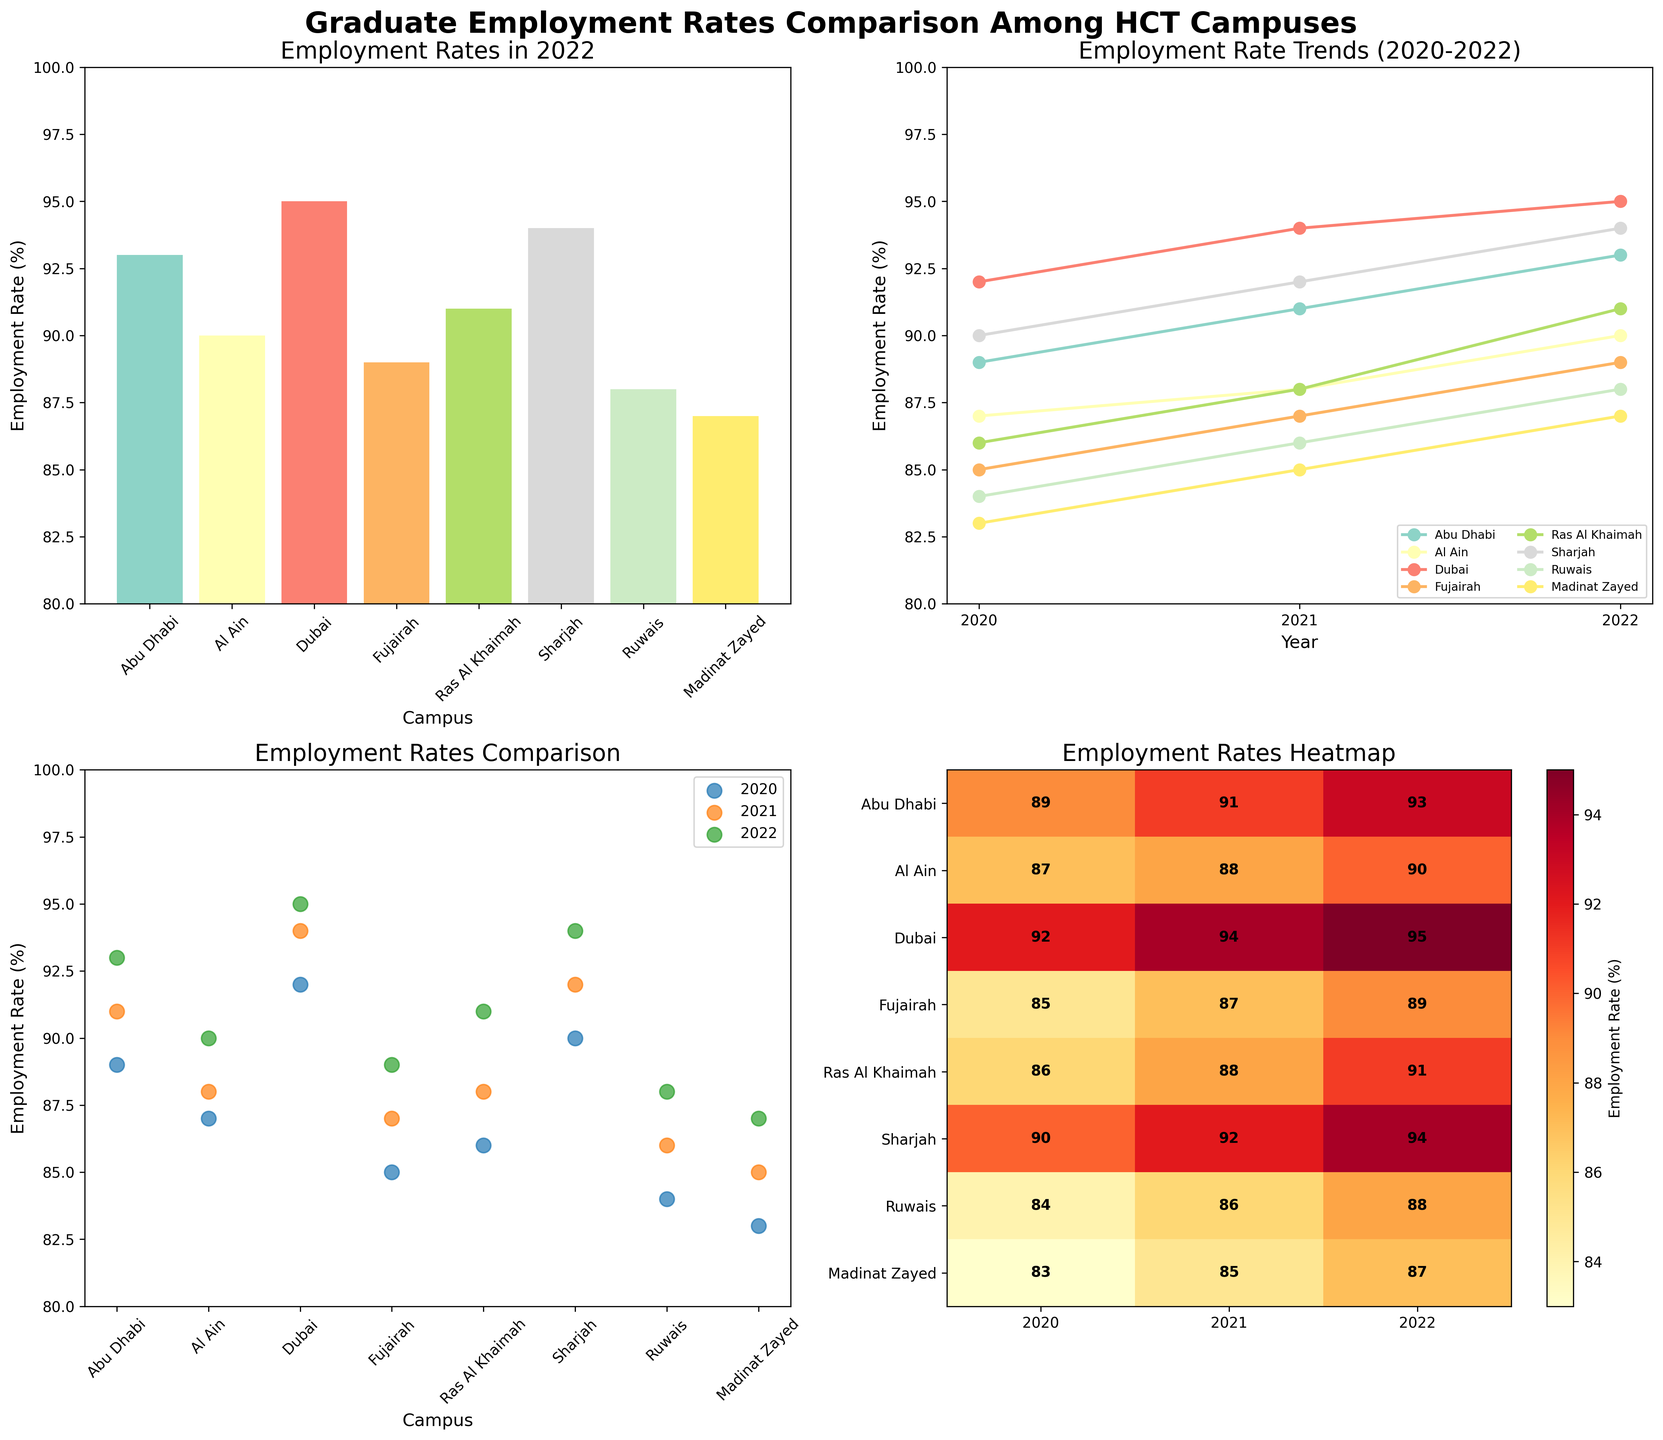What is the employment rate for Fujairah campus in 2022? The bar plot titled 'Employment Rates in 2022' shows the employment rates for various campuses. The bar representing the Fujairah campus reaches up to 89%.
Answer: 89% Which campus had the highest employment rate in 2022? By looking at the bar heights in the 'Employment Rates in 2022' plot, Dubai campus has the tallest bar, indicating the highest rate at 95%.
Answer: Dubai How did the employment rate for Ruwais campus change from 2020 to 2022? Examine the line plot labeled 'Employment Rate Trends (2020-2022)' and trace the line for Ruwais campus. In 2020, the rate started at 84%, moved to 86% in 2021, and reached 88% in 2022, showing a steady increase each year.
Answer: Increased steadily Compare the employment rates of Abu Dhabi and Al Ain campuses in the year 2022. Which one is higher and by how much? Looking at the bar plot for 2022, Abu Dhabi's rate is 93% and Al Ain's rate is 90%. Abu Dhabi's rate is higher by 3%.
Answer: Abu Dhabi is higher by 3% What is the average employment rate for Dubai campus over the years 2020 to 2022? In the line plot 'Employment Rate Trends (2020-2022)', find Dubai's rates: 92% in 2020, 94% in 2021, and 95% in 2022. Calculate the average: (92 + 94 + 95) / 3 = 93.67%.
Answer: 93.67% In the heatmap, which campus has the lowest employment rate in 2020? The heatmap provides visual intensity to signify rate percentages. The lowest value in the 2020 column is for Madinat Zayed campus, which is 83%.
Answer: Madinat Zayed Which campus shows the least variation in employment rates from 2020 to 2022? In the line plot 'Employment Rate Trends (2020-2022)', the campus with the most stable line is Al Ain, changing from 87% to 88% to 90%, a total variation of 3%.
Answer: Al Ain What is the sum of the employment rates for Sharjah campus from 2020 to 2022? Using the line plot, Sharjah's rates are 90% in 2020, 92% in 2021, and 94% in 2022. The sum is 90 + 92 + 94 = 276%.
Answer: 276% How does the employment rate trend for Ras Al Khaimah compare to Sharjah from 2020 to 2022? By observing the line plot, Ras Al Khaimah's line shows an increase from 86% to 88% to 91%, while Sharjah's goes from 90% to 92% to 94%. Both campuses show an increasing trend, but Sharjah starts higher and increases more consistently.
Answer: Sharjah has a higher starting rate and more consistent increase What color represents the Abu Dhabi campus in the scatter plot? The scatter plot uses different colors for each campus. The specific color can be noted by identifying the data point labels in the 'Employment Rates Comparison' scatter plot, where Abu Dhabi is represented before Al Ain.
Answer: Determined by identifying scatter plot colors 